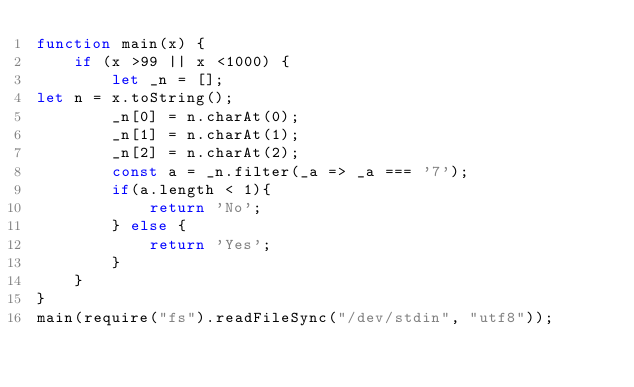Convert code to text. <code><loc_0><loc_0><loc_500><loc_500><_JavaScript_>function main(x) {
    if (x >99 || x <1000) {
        let _n = [];
let n = x.toString();
        _n[0] = n.charAt(0);
        _n[1] = n.charAt(1);
        _n[2] = n.charAt(2);
        const a = _n.filter(_a => _a === '7');
        if(a.length < 1){
            return 'No';
        } else {
            return 'Yes';
        }
    }
}
main(require("fs").readFileSync("/dev/stdin", "utf8"));</code> 